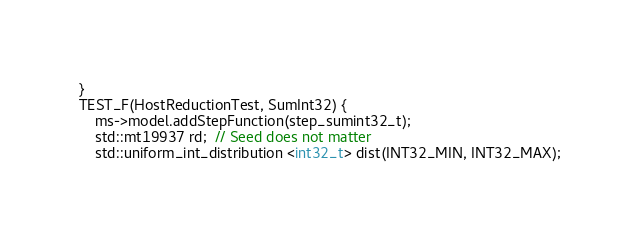Convert code to text. <code><loc_0><loc_0><loc_500><loc_500><_Cuda_>}
TEST_F(HostReductionTest, SumInt32) {
    ms->model.addStepFunction(step_sumint32_t);
    std::mt19937 rd;  // Seed does not matter
    std::uniform_int_distribution <int32_t> dist(INT32_MIN, INT32_MAX);</code> 